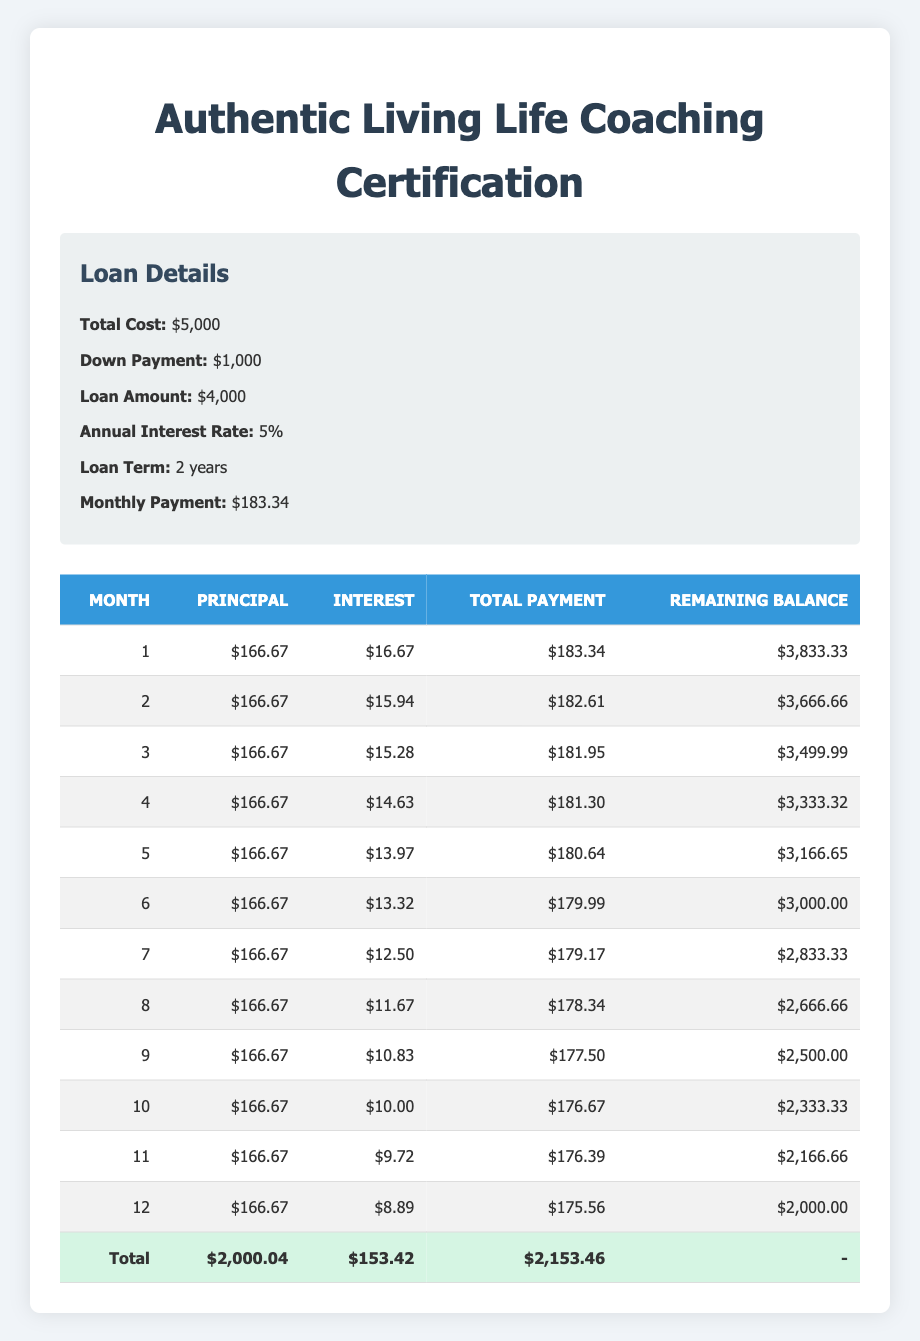What is the total monthly payment for the life coaching certification program? The total monthly payment can be found in the loan details section of the table, which states that the total monthly payment is $183.34.
Answer: 183.34 How much of the payment in the first month goes towards principal? In the first month, the principal payment is specifically listed in the payment schedule as $166.67.
Answer: 166.67 What is the remaining balance after the 6th month? To find the remaining balance after the 6th month, we refer to the payment schedule where the remaining balance for that month is specifically listed as $3,000.00.
Answer: 3000.00 What is the total amount paid in interest over the 12-month period? To find the total interest paid, we sum up the interest payments from the payment schedule. Adding them yields (16.67 + 15.94 + 15.28 + 14.63 + 13.97 + 13.32 + 12.50 + 11.67 + 10.83 + 10.00 + 9.72 + 8.89) = $153.42.
Answer: 153.42 Is the total monthly payment the same for all months? Yes, by observing the payment schedule, we can see that while the principal payment remains constant, the interest payment decreases in subsequent months. However, the total monthly payment gradually decreases, as the interest component shifts.
Answer: Yes In which month does the total payment fall below $180? By examining the payment schedule, we can see that the total payment falls below $180 in January (month 1 = $183.34) to April, and then it drops below $180 starting in month 5 ($180.64) and further declines in subsequent months to hit $175.56 in the last month (month 12). The first occurrence is in month 5.
Answer: 5 What is the average principal payment over the loan term? The principal payment is consistent at $166.67 every month. To find the average over 12 months, we can simply take this constant value: (166.67 * 12) / 12 = 166.67.
Answer: 166.67 How much will the borrower pay in total by the end of the loan term? To find the total amount paid over the loan term, we multiply the total monthly payment by the number of months: $183.34 * 12 = $2,200.08.
Answer: 2200.08 